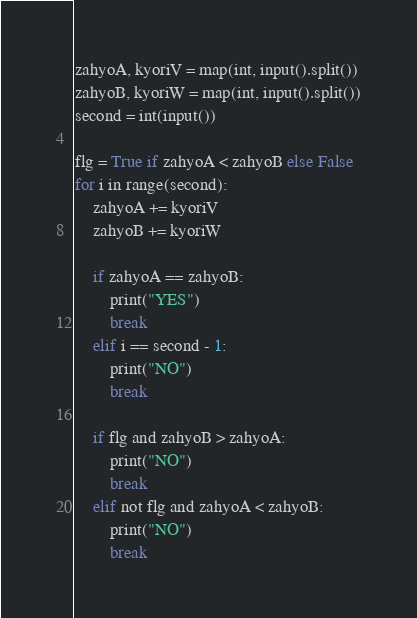Convert code to text. <code><loc_0><loc_0><loc_500><loc_500><_Python_>zahyoA, kyoriV = map(int, input().split())
zahyoB, kyoriW = map(int, input().split())
second = int(input())

flg = True if zahyoA < zahyoB else False 
for i in range(second):
    zahyoA += kyoriV
    zahyoB += kyoriW

    if zahyoA == zahyoB:
        print("YES")
        break
    elif i == second - 1:
        print("NO")
        break

    if flg and zahyoB > zahyoA:
        print("NO")
        break
    elif not flg and zahyoA < zahyoB:
        print("NO")
        break
</code> 